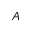<formula> <loc_0><loc_0><loc_500><loc_500>A</formula> 